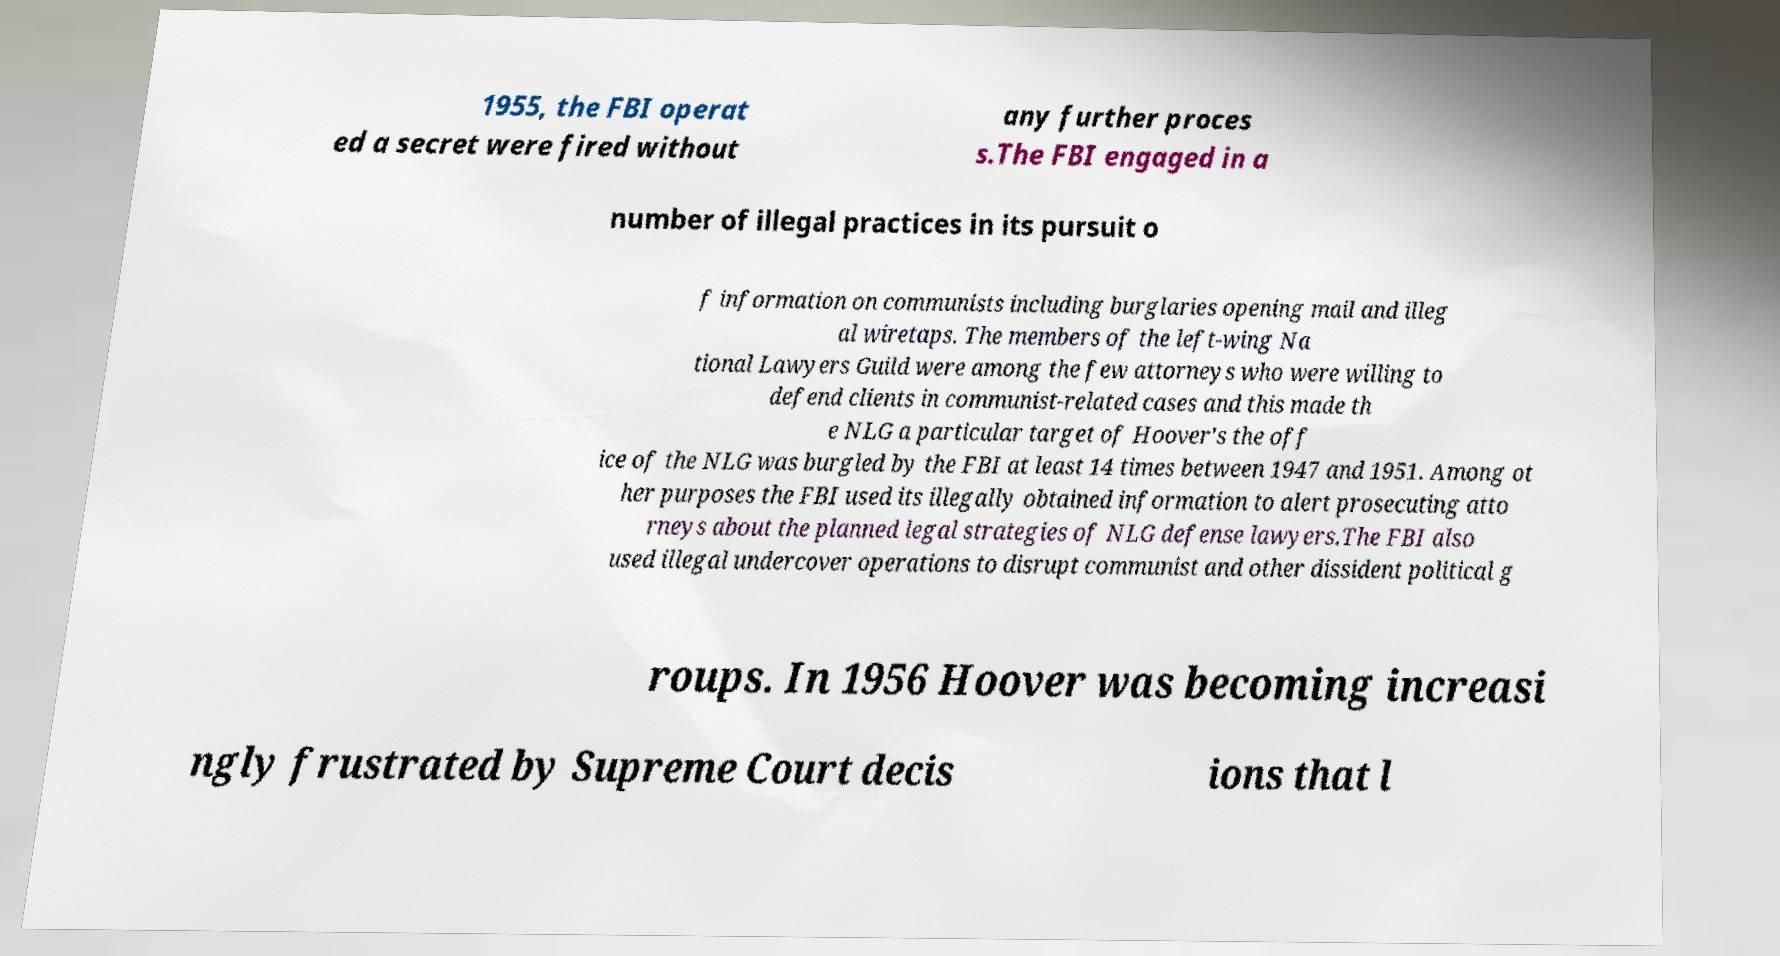Please read and relay the text visible in this image. What does it say? 1955, the FBI operat ed a secret were fired without any further proces s.The FBI engaged in a number of illegal practices in its pursuit o f information on communists including burglaries opening mail and illeg al wiretaps. The members of the left-wing Na tional Lawyers Guild were among the few attorneys who were willing to defend clients in communist-related cases and this made th e NLG a particular target of Hoover's the off ice of the NLG was burgled by the FBI at least 14 times between 1947 and 1951. Among ot her purposes the FBI used its illegally obtained information to alert prosecuting atto rneys about the planned legal strategies of NLG defense lawyers.The FBI also used illegal undercover operations to disrupt communist and other dissident political g roups. In 1956 Hoover was becoming increasi ngly frustrated by Supreme Court decis ions that l 